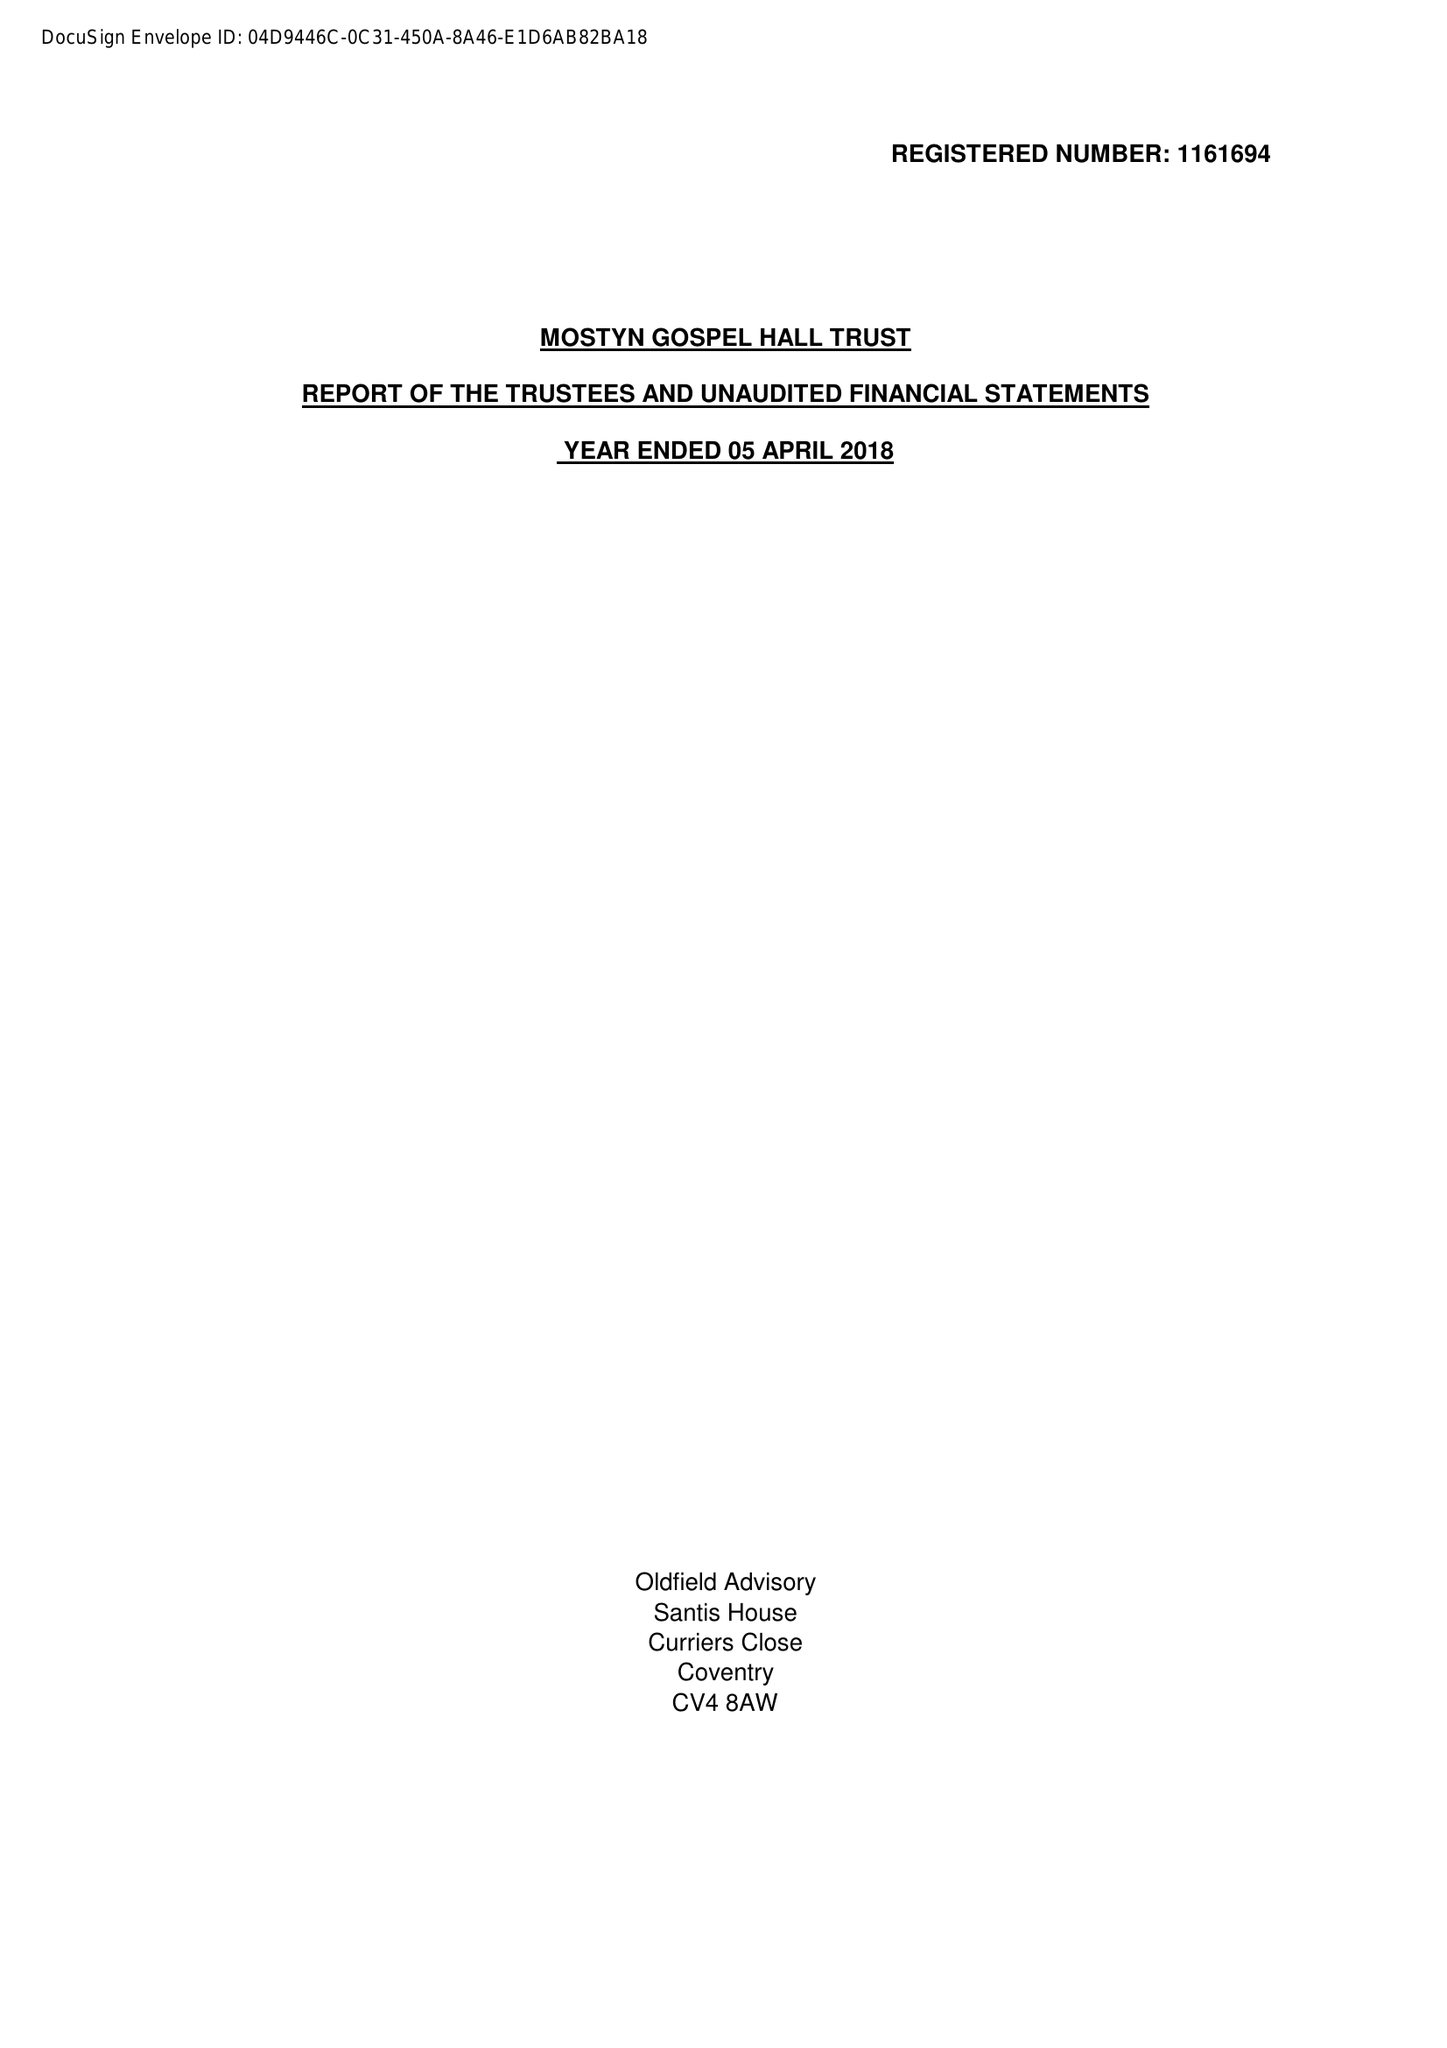What is the value for the spending_annually_in_british_pounds?
Answer the question using a single word or phrase. 21814.00 